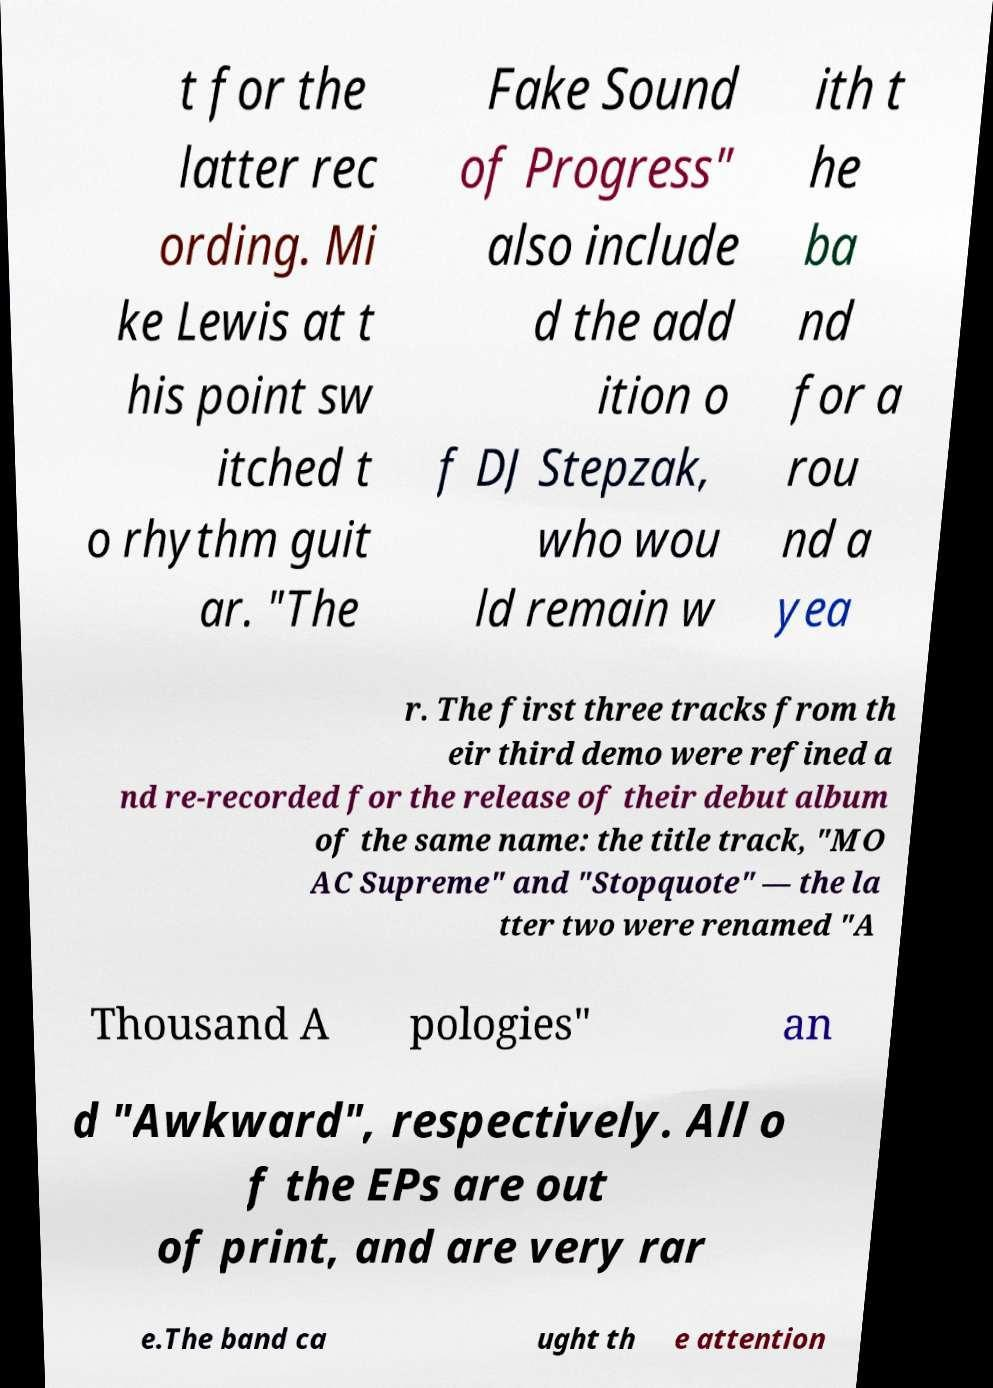I need the written content from this picture converted into text. Can you do that? t for the latter rec ording. Mi ke Lewis at t his point sw itched t o rhythm guit ar. "The Fake Sound of Progress" also include d the add ition o f DJ Stepzak, who wou ld remain w ith t he ba nd for a rou nd a yea r. The first three tracks from th eir third demo were refined a nd re-recorded for the release of their debut album of the same name: the title track, "MO AC Supreme" and "Stopquote" — the la tter two were renamed "A Thousand A pologies" an d "Awkward", respectively. All o f the EPs are out of print, and are very rar e.The band ca ught th e attention 